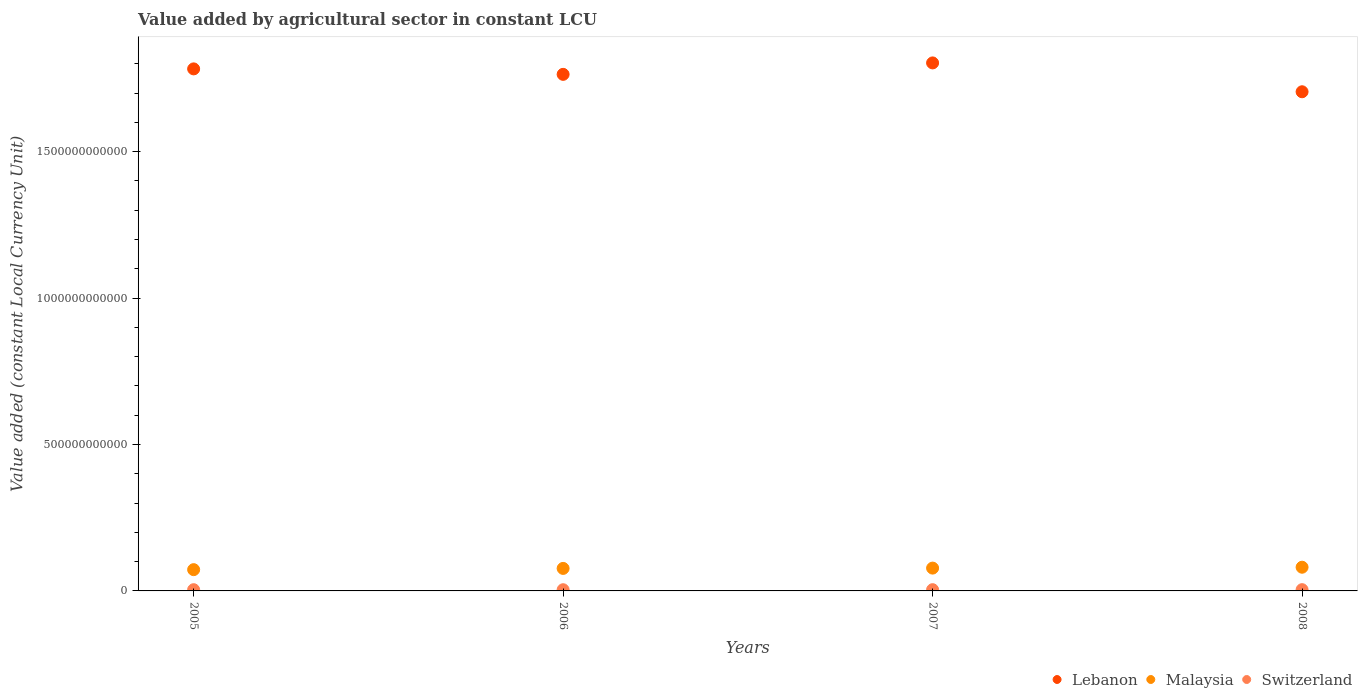Is the number of dotlines equal to the number of legend labels?
Your answer should be compact. Yes. What is the value added by agricultural sector in Switzerland in 2005?
Your response must be concise. 4.18e+09. Across all years, what is the maximum value added by agricultural sector in Malaysia?
Keep it short and to the point. 8.09e+1. Across all years, what is the minimum value added by agricultural sector in Switzerland?
Your answer should be very brief. 4.10e+09. In which year was the value added by agricultural sector in Switzerland maximum?
Offer a very short reply. 2008. What is the total value added by agricultural sector in Switzerland in the graph?
Make the answer very short. 1.68e+1. What is the difference between the value added by agricultural sector in Malaysia in 2007 and that in 2008?
Keep it short and to the point. -2.99e+09. What is the difference between the value added by agricultural sector in Lebanon in 2006 and the value added by agricultural sector in Switzerland in 2007?
Your answer should be very brief. 1.76e+12. What is the average value added by agricultural sector in Switzerland per year?
Your response must be concise. 4.21e+09. In the year 2008, what is the difference between the value added by agricultural sector in Lebanon and value added by agricultural sector in Switzerland?
Your response must be concise. 1.70e+12. What is the ratio of the value added by agricultural sector in Malaysia in 2006 to that in 2008?
Provide a short and direct response. 0.95. What is the difference between the highest and the second highest value added by agricultural sector in Malaysia?
Provide a short and direct response. 2.99e+09. What is the difference between the highest and the lowest value added by agricultural sector in Switzerland?
Provide a short and direct response. 2.06e+08. In how many years, is the value added by agricultural sector in Switzerland greater than the average value added by agricultural sector in Switzerland taken over all years?
Make the answer very short. 2. Is it the case that in every year, the sum of the value added by agricultural sector in Malaysia and value added by agricultural sector in Switzerland  is greater than the value added by agricultural sector in Lebanon?
Ensure brevity in your answer.  No. Is the value added by agricultural sector in Switzerland strictly greater than the value added by agricultural sector in Lebanon over the years?
Keep it short and to the point. No. Is the value added by agricultural sector in Malaysia strictly less than the value added by agricultural sector in Switzerland over the years?
Offer a very short reply. No. How many dotlines are there?
Provide a short and direct response. 3. What is the difference between two consecutive major ticks on the Y-axis?
Provide a succinct answer. 5.00e+11. Does the graph contain grids?
Your answer should be very brief. No. How many legend labels are there?
Your response must be concise. 3. What is the title of the graph?
Keep it short and to the point. Value added by agricultural sector in constant LCU. What is the label or title of the Y-axis?
Provide a succinct answer. Value added (constant Local Currency Unit). What is the Value added (constant Local Currency Unit) in Lebanon in 2005?
Your answer should be compact. 1.78e+12. What is the Value added (constant Local Currency Unit) in Malaysia in 2005?
Give a very brief answer. 7.26e+1. What is the Value added (constant Local Currency Unit) of Switzerland in 2005?
Provide a short and direct response. 4.18e+09. What is the Value added (constant Local Currency Unit) of Lebanon in 2006?
Your response must be concise. 1.76e+12. What is the Value added (constant Local Currency Unit) of Malaysia in 2006?
Offer a very short reply. 7.68e+1. What is the Value added (constant Local Currency Unit) of Switzerland in 2006?
Ensure brevity in your answer.  4.10e+09. What is the Value added (constant Local Currency Unit) of Lebanon in 2007?
Your response must be concise. 1.80e+12. What is the Value added (constant Local Currency Unit) of Malaysia in 2007?
Ensure brevity in your answer.  7.79e+1. What is the Value added (constant Local Currency Unit) in Switzerland in 2007?
Your response must be concise. 4.24e+09. What is the Value added (constant Local Currency Unit) of Lebanon in 2008?
Offer a very short reply. 1.70e+12. What is the Value added (constant Local Currency Unit) in Malaysia in 2008?
Offer a very short reply. 8.09e+1. What is the Value added (constant Local Currency Unit) of Switzerland in 2008?
Provide a short and direct response. 4.31e+09. Across all years, what is the maximum Value added (constant Local Currency Unit) in Lebanon?
Give a very brief answer. 1.80e+12. Across all years, what is the maximum Value added (constant Local Currency Unit) in Malaysia?
Your answer should be compact. 8.09e+1. Across all years, what is the maximum Value added (constant Local Currency Unit) of Switzerland?
Offer a terse response. 4.31e+09. Across all years, what is the minimum Value added (constant Local Currency Unit) in Lebanon?
Make the answer very short. 1.70e+12. Across all years, what is the minimum Value added (constant Local Currency Unit) in Malaysia?
Provide a succinct answer. 7.26e+1. Across all years, what is the minimum Value added (constant Local Currency Unit) in Switzerland?
Ensure brevity in your answer.  4.10e+09. What is the total Value added (constant Local Currency Unit) in Lebanon in the graph?
Make the answer very short. 7.05e+12. What is the total Value added (constant Local Currency Unit) of Malaysia in the graph?
Keep it short and to the point. 3.08e+11. What is the total Value added (constant Local Currency Unit) in Switzerland in the graph?
Offer a terse response. 1.68e+1. What is the difference between the Value added (constant Local Currency Unit) of Lebanon in 2005 and that in 2006?
Make the answer very short. 1.87e+1. What is the difference between the Value added (constant Local Currency Unit) of Malaysia in 2005 and that in 2006?
Offer a terse response. -4.24e+09. What is the difference between the Value added (constant Local Currency Unit) of Switzerland in 2005 and that in 2006?
Provide a succinct answer. 7.24e+07. What is the difference between the Value added (constant Local Currency Unit) in Lebanon in 2005 and that in 2007?
Offer a terse response. -2.04e+1. What is the difference between the Value added (constant Local Currency Unit) in Malaysia in 2005 and that in 2007?
Give a very brief answer. -5.30e+09. What is the difference between the Value added (constant Local Currency Unit) in Switzerland in 2005 and that in 2007?
Give a very brief answer. -6.03e+07. What is the difference between the Value added (constant Local Currency Unit) in Lebanon in 2005 and that in 2008?
Give a very brief answer. 7.81e+1. What is the difference between the Value added (constant Local Currency Unit) in Malaysia in 2005 and that in 2008?
Ensure brevity in your answer.  -8.28e+09. What is the difference between the Value added (constant Local Currency Unit) in Switzerland in 2005 and that in 2008?
Your answer should be compact. -1.33e+08. What is the difference between the Value added (constant Local Currency Unit) in Lebanon in 2006 and that in 2007?
Offer a terse response. -3.91e+1. What is the difference between the Value added (constant Local Currency Unit) of Malaysia in 2006 and that in 2007?
Make the answer very short. -1.06e+09. What is the difference between the Value added (constant Local Currency Unit) of Switzerland in 2006 and that in 2007?
Make the answer very short. -1.33e+08. What is the difference between the Value added (constant Local Currency Unit) of Lebanon in 2006 and that in 2008?
Offer a very short reply. 5.94e+1. What is the difference between the Value added (constant Local Currency Unit) in Malaysia in 2006 and that in 2008?
Offer a terse response. -4.05e+09. What is the difference between the Value added (constant Local Currency Unit) in Switzerland in 2006 and that in 2008?
Your answer should be compact. -2.06e+08. What is the difference between the Value added (constant Local Currency Unit) in Lebanon in 2007 and that in 2008?
Provide a short and direct response. 9.85e+1. What is the difference between the Value added (constant Local Currency Unit) in Malaysia in 2007 and that in 2008?
Your response must be concise. -2.99e+09. What is the difference between the Value added (constant Local Currency Unit) of Switzerland in 2007 and that in 2008?
Your answer should be very brief. -7.31e+07. What is the difference between the Value added (constant Local Currency Unit) of Lebanon in 2005 and the Value added (constant Local Currency Unit) of Malaysia in 2006?
Ensure brevity in your answer.  1.71e+12. What is the difference between the Value added (constant Local Currency Unit) of Lebanon in 2005 and the Value added (constant Local Currency Unit) of Switzerland in 2006?
Ensure brevity in your answer.  1.78e+12. What is the difference between the Value added (constant Local Currency Unit) in Malaysia in 2005 and the Value added (constant Local Currency Unit) in Switzerland in 2006?
Ensure brevity in your answer.  6.85e+1. What is the difference between the Value added (constant Local Currency Unit) of Lebanon in 2005 and the Value added (constant Local Currency Unit) of Malaysia in 2007?
Make the answer very short. 1.70e+12. What is the difference between the Value added (constant Local Currency Unit) in Lebanon in 2005 and the Value added (constant Local Currency Unit) in Switzerland in 2007?
Offer a terse response. 1.78e+12. What is the difference between the Value added (constant Local Currency Unit) in Malaysia in 2005 and the Value added (constant Local Currency Unit) in Switzerland in 2007?
Provide a short and direct response. 6.84e+1. What is the difference between the Value added (constant Local Currency Unit) of Lebanon in 2005 and the Value added (constant Local Currency Unit) of Malaysia in 2008?
Keep it short and to the point. 1.70e+12. What is the difference between the Value added (constant Local Currency Unit) in Lebanon in 2005 and the Value added (constant Local Currency Unit) in Switzerland in 2008?
Your answer should be compact. 1.78e+12. What is the difference between the Value added (constant Local Currency Unit) in Malaysia in 2005 and the Value added (constant Local Currency Unit) in Switzerland in 2008?
Make the answer very short. 6.83e+1. What is the difference between the Value added (constant Local Currency Unit) of Lebanon in 2006 and the Value added (constant Local Currency Unit) of Malaysia in 2007?
Offer a very short reply. 1.69e+12. What is the difference between the Value added (constant Local Currency Unit) in Lebanon in 2006 and the Value added (constant Local Currency Unit) in Switzerland in 2007?
Provide a short and direct response. 1.76e+12. What is the difference between the Value added (constant Local Currency Unit) of Malaysia in 2006 and the Value added (constant Local Currency Unit) of Switzerland in 2007?
Provide a succinct answer. 7.26e+1. What is the difference between the Value added (constant Local Currency Unit) of Lebanon in 2006 and the Value added (constant Local Currency Unit) of Malaysia in 2008?
Give a very brief answer. 1.68e+12. What is the difference between the Value added (constant Local Currency Unit) in Lebanon in 2006 and the Value added (constant Local Currency Unit) in Switzerland in 2008?
Your answer should be compact. 1.76e+12. What is the difference between the Value added (constant Local Currency Unit) in Malaysia in 2006 and the Value added (constant Local Currency Unit) in Switzerland in 2008?
Provide a succinct answer. 7.25e+1. What is the difference between the Value added (constant Local Currency Unit) of Lebanon in 2007 and the Value added (constant Local Currency Unit) of Malaysia in 2008?
Make the answer very short. 1.72e+12. What is the difference between the Value added (constant Local Currency Unit) in Lebanon in 2007 and the Value added (constant Local Currency Unit) in Switzerland in 2008?
Give a very brief answer. 1.80e+12. What is the difference between the Value added (constant Local Currency Unit) of Malaysia in 2007 and the Value added (constant Local Currency Unit) of Switzerland in 2008?
Make the answer very short. 7.36e+1. What is the average Value added (constant Local Currency Unit) of Lebanon per year?
Your answer should be very brief. 1.76e+12. What is the average Value added (constant Local Currency Unit) in Malaysia per year?
Ensure brevity in your answer.  7.71e+1. What is the average Value added (constant Local Currency Unit) in Switzerland per year?
Offer a terse response. 4.21e+09. In the year 2005, what is the difference between the Value added (constant Local Currency Unit) of Lebanon and Value added (constant Local Currency Unit) of Malaysia?
Offer a very short reply. 1.71e+12. In the year 2005, what is the difference between the Value added (constant Local Currency Unit) in Lebanon and Value added (constant Local Currency Unit) in Switzerland?
Your answer should be compact. 1.78e+12. In the year 2005, what is the difference between the Value added (constant Local Currency Unit) of Malaysia and Value added (constant Local Currency Unit) of Switzerland?
Keep it short and to the point. 6.84e+1. In the year 2006, what is the difference between the Value added (constant Local Currency Unit) of Lebanon and Value added (constant Local Currency Unit) of Malaysia?
Give a very brief answer. 1.69e+12. In the year 2006, what is the difference between the Value added (constant Local Currency Unit) of Lebanon and Value added (constant Local Currency Unit) of Switzerland?
Offer a very short reply. 1.76e+12. In the year 2006, what is the difference between the Value added (constant Local Currency Unit) of Malaysia and Value added (constant Local Currency Unit) of Switzerland?
Give a very brief answer. 7.27e+1. In the year 2007, what is the difference between the Value added (constant Local Currency Unit) in Lebanon and Value added (constant Local Currency Unit) in Malaysia?
Your answer should be compact. 1.72e+12. In the year 2007, what is the difference between the Value added (constant Local Currency Unit) in Lebanon and Value added (constant Local Currency Unit) in Switzerland?
Provide a short and direct response. 1.80e+12. In the year 2007, what is the difference between the Value added (constant Local Currency Unit) of Malaysia and Value added (constant Local Currency Unit) of Switzerland?
Your response must be concise. 7.37e+1. In the year 2008, what is the difference between the Value added (constant Local Currency Unit) in Lebanon and Value added (constant Local Currency Unit) in Malaysia?
Offer a very short reply. 1.62e+12. In the year 2008, what is the difference between the Value added (constant Local Currency Unit) of Lebanon and Value added (constant Local Currency Unit) of Switzerland?
Your answer should be compact. 1.70e+12. In the year 2008, what is the difference between the Value added (constant Local Currency Unit) in Malaysia and Value added (constant Local Currency Unit) in Switzerland?
Offer a very short reply. 7.66e+1. What is the ratio of the Value added (constant Local Currency Unit) in Lebanon in 2005 to that in 2006?
Your response must be concise. 1.01. What is the ratio of the Value added (constant Local Currency Unit) in Malaysia in 2005 to that in 2006?
Offer a terse response. 0.94. What is the ratio of the Value added (constant Local Currency Unit) of Switzerland in 2005 to that in 2006?
Keep it short and to the point. 1.02. What is the ratio of the Value added (constant Local Currency Unit) of Lebanon in 2005 to that in 2007?
Your response must be concise. 0.99. What is the ratio of the Value added (constant Local Currency Unit) in Malaysia in 2005 to that in 2007?
Your answer should be very brief. 0.93. What is the ratio of the Value added (constant Local Currency Unit) in Switzerland in 2005 to that in 2007?
Give a very brief answer. 0.99. What is the ratio of the Value added (constant Local Currency Unit) of Lebanon in 2005 to that in 2008?
Give a very brief answer. 1.05. What is the ratio of the Value added (constant Local Currency Unit) in Malaysia in 2005 to that in 2008?
Offer a very short reply. 0.9. What is the ratio of the Value added (constant Local Currency Unit) of Lebanon in 2006 to that in 2007?
Keep it short and to the point. 0.98. What is the ratio of the Value added (constant Local Currency Unit) of Malaysia in 2006 to that in 2007?
Offer a terse response. 0.99. What is the ratio of the Value added (constant Local Currency Unit) in Switzerland in 2006 to that in 2007?
Ensure brevity in your answer.  0.97. What is the ratio of the Value added (constant Local Currency Unit) of Lebanon in 2006 to that in 2008?
Your answer should be compact. 1.03. What is the ratio of the Value added (constant Local Currency Unit) of Malaysia in 2006 to that in 2008?
Make the answer very short. 0.95. What is the ratio of the Value added (constant Local Currency Unit) of Switzerland in 2006 to that in 2008?
Provide a succinct answer. 0.95. What is the ratio of the Value added (constant Local Currency Unit) in Lebanon in 2007 to that in 2008?
Your answer should be compact. 1.06. What is the ratio of the Value added (constant Local Currency Unit) in Malaysia in 2007 to that in 2008?
Ensure brevity in your answer.  0.96. What is the ratio of the Value added (constant Local Currency Unit) of Switzerland in 2007 to that in 2008?
Offer a very short reply. 0.98. What is the difference between the highest and the second highest Value added (constant Local Currency Unit) of Lebanon?
Give a very brief answer. 2.04e+1. What is the difference between the highest and the second highest Value added (constant Local Currency Unit) in Malaysia?
Your answer should be compact. 2.99e+09. What is the difference between the highest and the second highest Value added (constant Local Currency Unit) in Switzerland?
Provide a succinct answer. 7.31e+07. What is the difference between the highest and the lowest Value added (constant Local Currency Unit) in Lebanon?
Make the answer very short. 9.85e+1. What is the difference between the highest and the lowest Value added (constant Local Currency Unit) of Malaysia?
Provide a succinct answer. 8.28e+09. What is the difference between the highest and the lowest Value added (constant Local Currency Unit) of Switzerland?
Keep it short and to the point. 2.06e+08. 